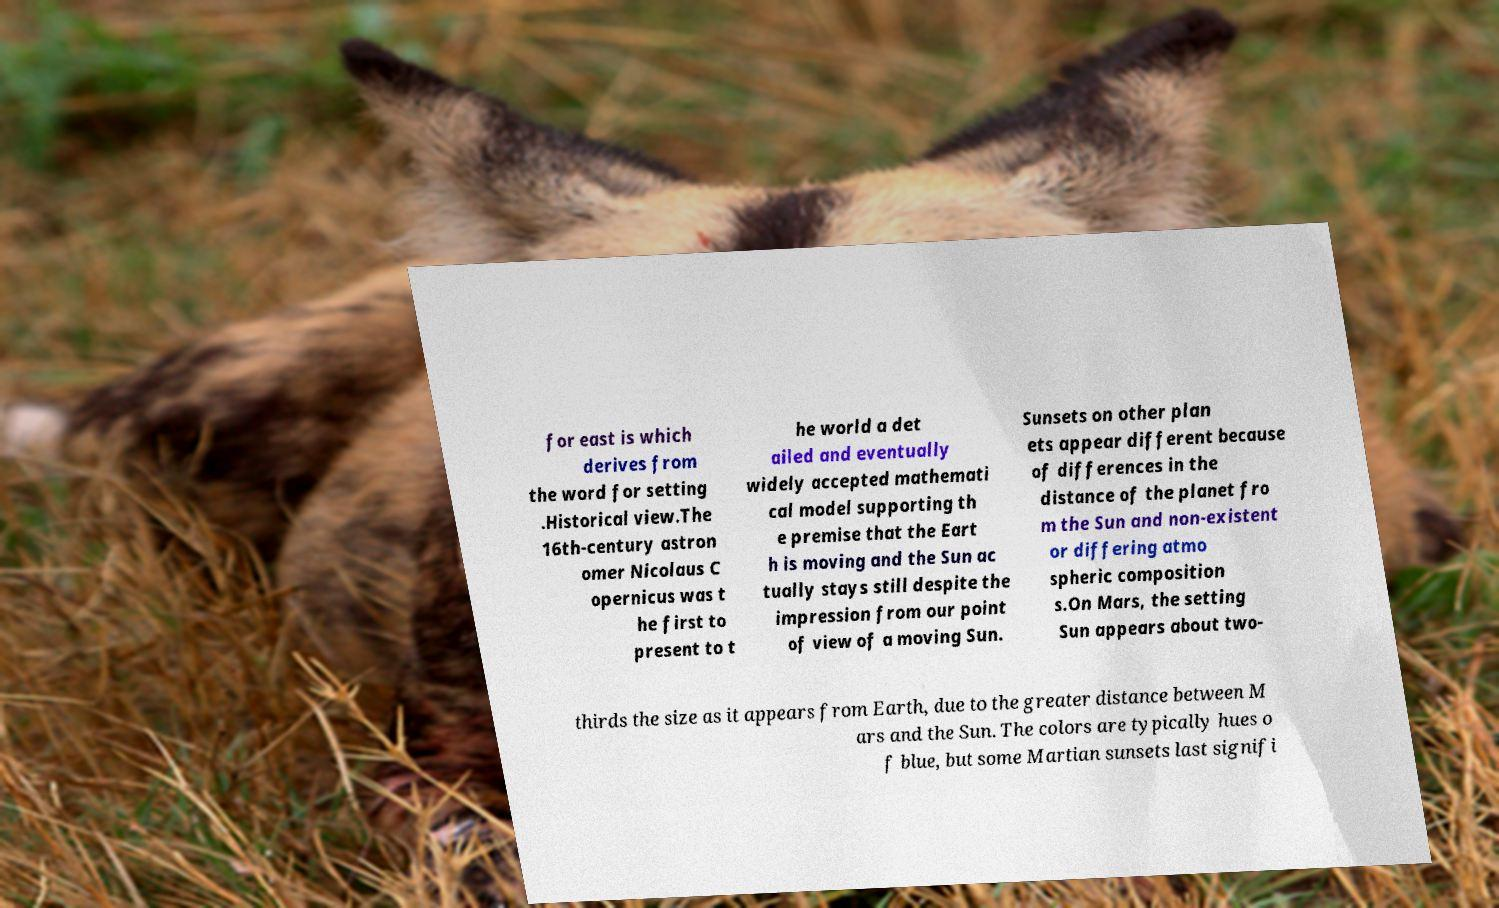Can you read and provide the text displayed in the image?This photo seems to have some interesting text. Can you extract and type it out for me? for east is which derives from the word for setting .Historical view.The 16th-century astron omer Nicolaus C opernicus was t he first to present to t he world a det ailed and eventually widely accepted mathemati cal model supporting th e premise that the Eart h is moving and the Sun ac tually stays still despite the impression from our point of view of a moving Sun. Sunsets on other plan ets appear different because of differences in the distance of the planet fro m the Sun and non-existent or differing atmo spheric composition s.On Mars, the setting Sun appears about two- thirds the size as it appears from Earth, due to the greater distance between M ars and the Sun. The colors are typically hues o f blue, but some Martian sunsets last signifi 